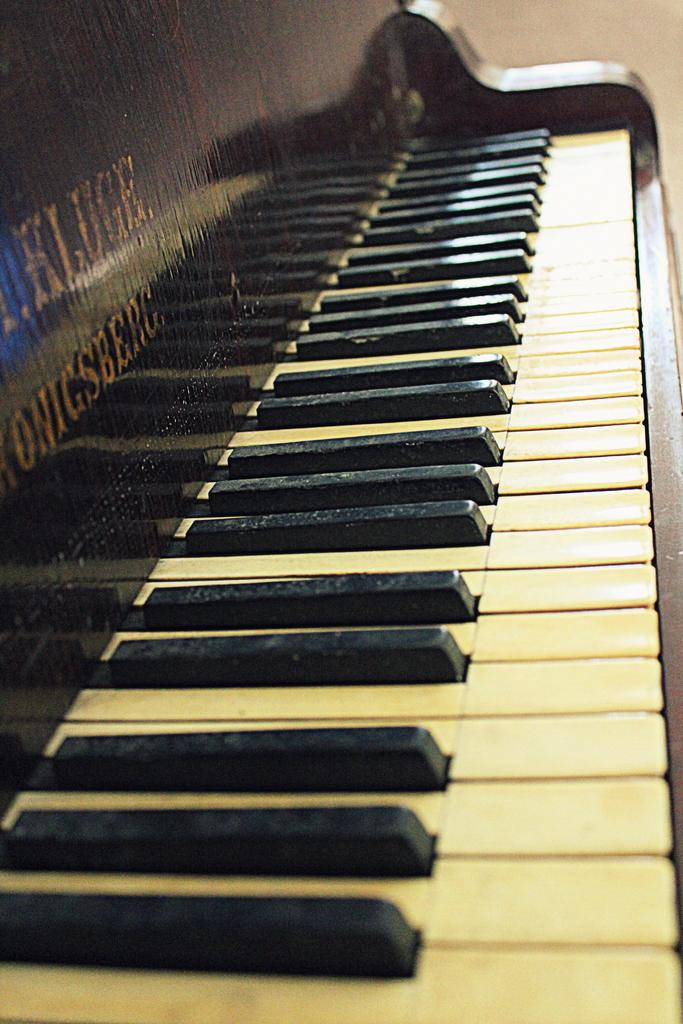What musical instrument is present in the image? There is a piano in the image. What are the two types of keys on the piano? The piano has white keys and black keys. How many icicles are hanging from the piano in the image? There are no icicles present in the image; it features a piano with white and black keys. What type of animal can be seen grazing near the piano in the image? There are no animals present in the image; it features a piano with white and black keys. 